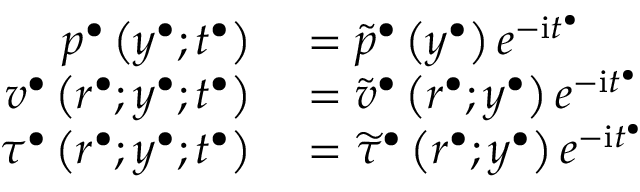<formula> <loc_0><loc_0><loc_500><loc_500>\begin{array} { r l } { p ^ { \bullet } \left ( y ^ { \bullet } ; t ^ { \bullet } \right ) } & = \widetilde { p } ^ { \bullet } \left ( y ^ { \bullet } \right ) e ^ { - i t ^ { \bullet } } } \\ { v ^ { \bullet } \left ( r ^ { \bullet } ; y ^ { \bullet } ; t ^ { \bullet } \right ) } & = \widetilde { v } ^ { \bullet } \left ( r ^ { \bullet } ; y ^ { \bullet } \right ) e ^ { - i t ^ { \bullet } } } \\ { \tau ^ { \bullet } \left ( r ^ { \bullet } ; y ^ { \bullet } ; t ^ { \bullet } \right ) } & = \widetilde { \tau } ^ { \bullet } \left ( r ^ { \bullet } ; y ^ { \bullet } \right ) e ^ { - i t ^ { \bullet } } } \end{array}</formula> 